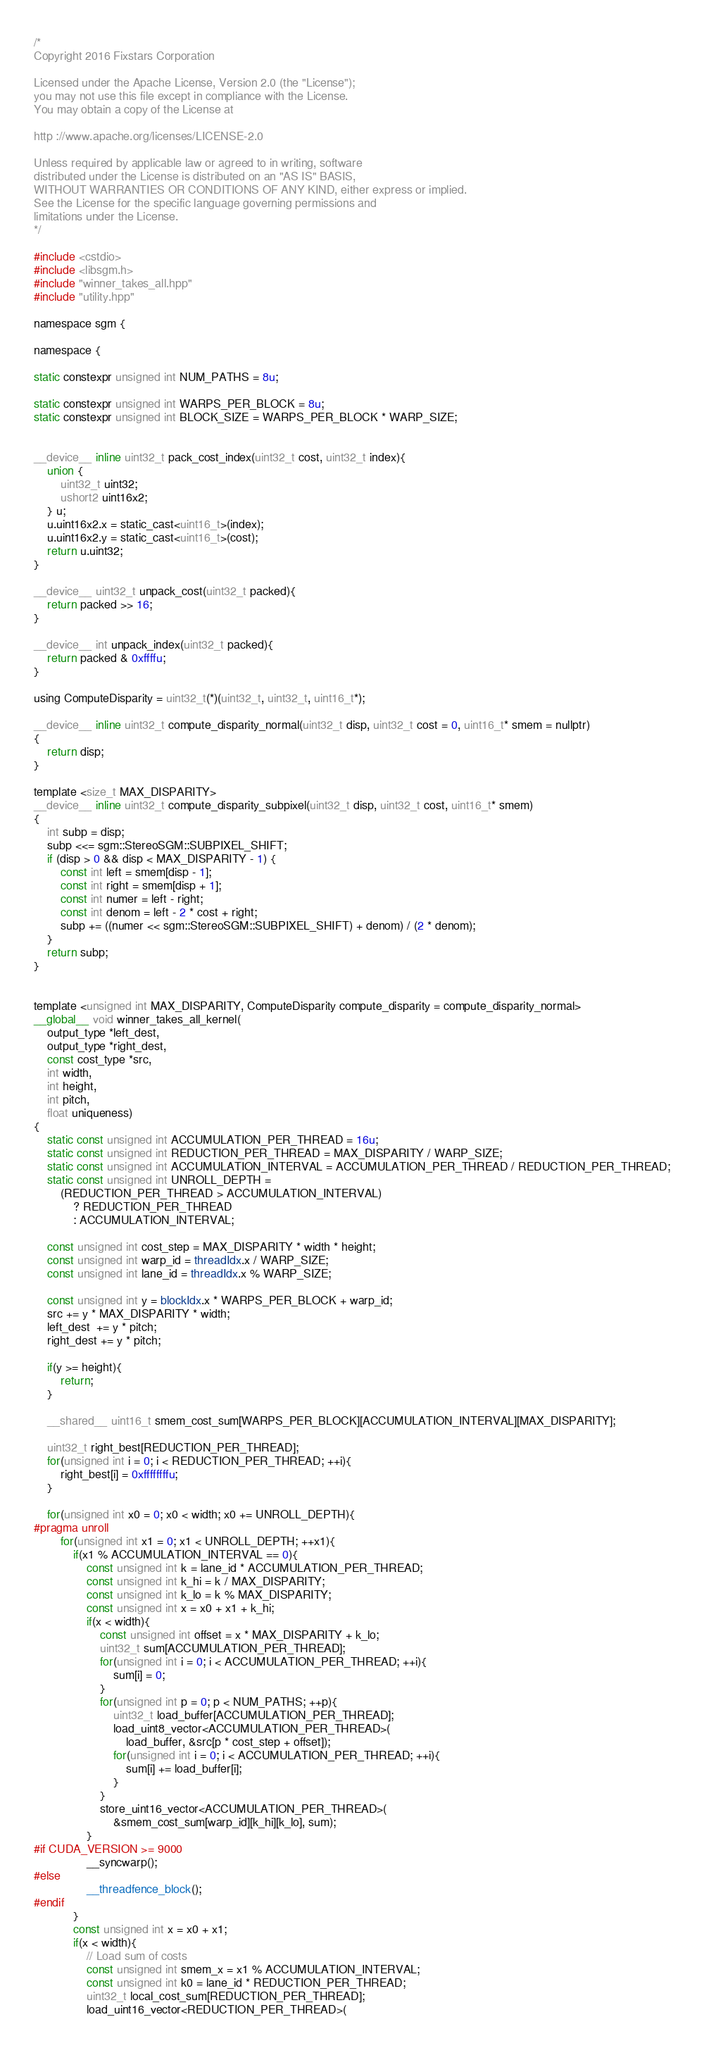Convert code to text. <code><loc_0><loc_0><loc_500><loc_500><_Cuda_>/*
Copyright 2016 Fixstars Corporation

Licensed under the Apache License, Version 2.0 (the "License");
you may not use this file except in compliance with the License.
You may obtain a copy of the License at

http ://www.apache.org/licenses/LICENSE-2.0

Unless required by applicable law or agreed to in writing, software
distributed under the License is distributed on an "AS IS" BASIS,
WITHOUT WARRANTIES OR CONDITIONS OF ANY KIND, either express or implied.
See the License for the specific language governing permissions and
limitations under the License.
*/

#include <cstdio>
#include <libsgm.h>
#include "winner_takes_all.hpp"
#include "utility.hpp"

namespace sgm {

namespace {

static constexpr unsigned int NUM_PATHS = 8u;

static constexpr unsigned int WARPS_PER_BLOCK = 8u;
static constexpr unsigned int BLOCK_SIZE = WARPS_PER_BLOCK * WARP_SIZE;


__device__ inline uint32_t pack_cost_index(uint32_t cost, uint32_t index){
	union {
		uint32_t uint32;
		ushort2 uint16x2;
	} u;
	u.uint16x2.x = static_cast<uint16_t>(index);
	u.uint16x2.y = static_cast<uint16_t>(cost);
	return u.uint32;
}

__device__ uint32_t unpack_cost(uint32_t packed){
	return packed >> 16;
}

__device__ int unpack_index(uint32_t packed){
	return packed & 0xffffu;
}

using ComputeDisparity = uint32_t(*)(uint32_t, uint32_t, uint16_t*);

__device__ inline uint32_t compute_disparity_normal(uint32_t disp, uint32_t cost = 0, uint16_t* smem = nullptr)
{
	return disp;
}

template <size_t MAX_DISPARITY>
__device__ inline uint32_t compute_disparity_subpixel(uint32_t disp, uint32_t cost, uint16_t* smem)
{
	int subp = disp;
	subp <<= sgm::StereoSGM::SUBPIXEL_SHIFT;
	if (disp > 0 && disp < MAX_DISPARITY - 1) {
		const int left = smem[disp - 1];
		const int right = smem[disp + 1];
		const int numer = left - right;
		const int denom = left - 2 * cost + right;
		subp += ((numer << sgm::StereoSGM::SUBPIXEL_SHIFT) + denom) / (2 * denom);
	}
	return subp;
}


template <unsigned int MAX_DISPARITY, ComputeDisparity compute_disparity = compute_disparity_normal>
__global__ void winner_takes_all_kernel(
	output_type *left_dest,
	output_type *right_dest,
	const cost_type *src,
	int width,
	int height,
	int pitch,
	float uniqueness)
{
	static const unsigned int ACCUMULATION_PER_THREAD = 16u;
	static const unsigned int REDUCTION_PER_THREAD = MAX_DISPARITY / WARP_SIZE;
	static const unsigned int ACCUMULATION_INTERVAL = ACCUMULATION_PER_THREAD / REDUCTION_PER_THREAD;
	static const unsigned int UNROLL_DEPTH = 
		(REDUCTION_PER_THREAD > ACCUMULATION_INTERVAL)
			? REDUCTION_PER_THREAD
			: ACCUMULATION_INTERVAL;

	const unsigned int cost_step = MAX_DISPARITY * width * height;
	const unsigned int warp_id = threadIdx.x / WARP_SIZE;
	const unsigned int lane_id = threadIdx.x % WARP_SIZE;

	const unsigned int y = blockIdx.x * WARPS_PER_BLOCK + warp_id;
	src += y * MAX_DISPARITY * width;
	left_dest  += y * pitch;
	right_dest += y * pitch;

	if(y >= height){
		return;
	}

	__shared__ uint16_t smem_cost_sum[WARPS_PER_BLOCK][ACCUMULATION_INTERVAL][MAX_DISPARITY];

	uint32_t right_best[REDUCTION_PER_THREAD];
	for(unsigned int i = 0; i < REDUCTION_PER_THREAD; ++i){
		right_best[i] = 0xffffffffu;
	}

	for(unsigned int x0 = 0; x0 < width; x0 += UNROLL_DEPTH){
#pragma unroll
		for(unsigned int x1 = 0; x1 < UNROLL_DEPTH; ++x1){
			if(x1 % ACCUMULATION_INTERVAL == 0){
				const unsigned int k = lane_id * ACCUMULATION_PER_THREAD;
				const unsigned int k_hi = k / MAX_DISPARITY;
				const unsigned int k_lo = k % MAX_DISPARITY;
				const unsigned int x = x0 + x1 + k_hi;
				if(x < width){
					const unsigned int offset = x * MAX_DISPARITY + k_lo;
					uint32_t sum[ACCUMULATION_PER_THREAD];
					for(unsigned int i = 0; i < ACCUMULATION_PER_THREAD; ++i){
						sum[i] = 0;
					}
					for(unsigned int p = 0; p < NUM_PATHS; ++p){
						uint32_t load_buffer[ACCUMULATION_PER_THREAD];
						load_uint8_vector<ACCUMULATION_PER_THREAD>(
							load_buffer, &src[p * cost_step + offset]);
						for(unsigned int i = 0; i < ACCUMULATION_PER_THREAD; ++i){
							sum[i] += load_buffer[i];
						}
					}
					store_uint16_vector<ACCUMULATION_PER_THREAD>(
						&smem_cost_sum[warp_id][k_hi][k_lo], sum);
				}
#if CUDA_VERSION >= 9000
				__syncwarp();
#else
				__threadfence_block();
#endif
			}
			const unsigned int x = x0 + x1;
			if(x < width){
				// Load sum of costs
				const unsigned int smem_x = x1 % ACCUMULATION_INTERVAL;
				const unsigned int k0 = lane_id * REDUCTION_PER_THREAD;
				uint32_t local_cost_sum[REDUCTION_PER_THREAD];
				load_uint16_vector<REDUCTION_PER_THREAD>(</code> 